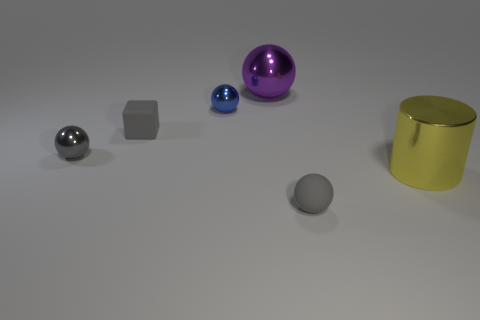What is the material of the blue thing that is the same shape as the large purple shiny thing?
Your response must be concise. Metal. Are there any small cyan shiny things?
Provide a succinct answer. No. There is a gray thing that is the same material as the gray cube; what is its shape?
Give a very brief answer. Sphere. There is a tiny gray object in front of the big yellow metallic cylinder; what material is it?
Ensure brevity in your answer.  Rubber. There is a rubber thing behind the tiny gray shiny thing; is it the same color as the tiny rubber ball?
Your answer should be compact. Yes. How big is the metal cylinder that is in front of the small rubber thing that is to the left of the purple thing?
Offer a very short reply. Large. Are there more cylinders in front of the gray shiny object than large blue objects?
Provide a succinct answer. Yes. Do the gray ball that is on the left side of the matte cube and the purple sphere have the same size?
Your answer should be very brief. No. What color is the metal object that is both on the right side of the blue metal sphere and in front of the big purple metal sphere?
Provide a succinct answer. Yellow. What is the shape of the metal object that is the same size as the purple sphere?
Give a very brief answer. Cylinder. 